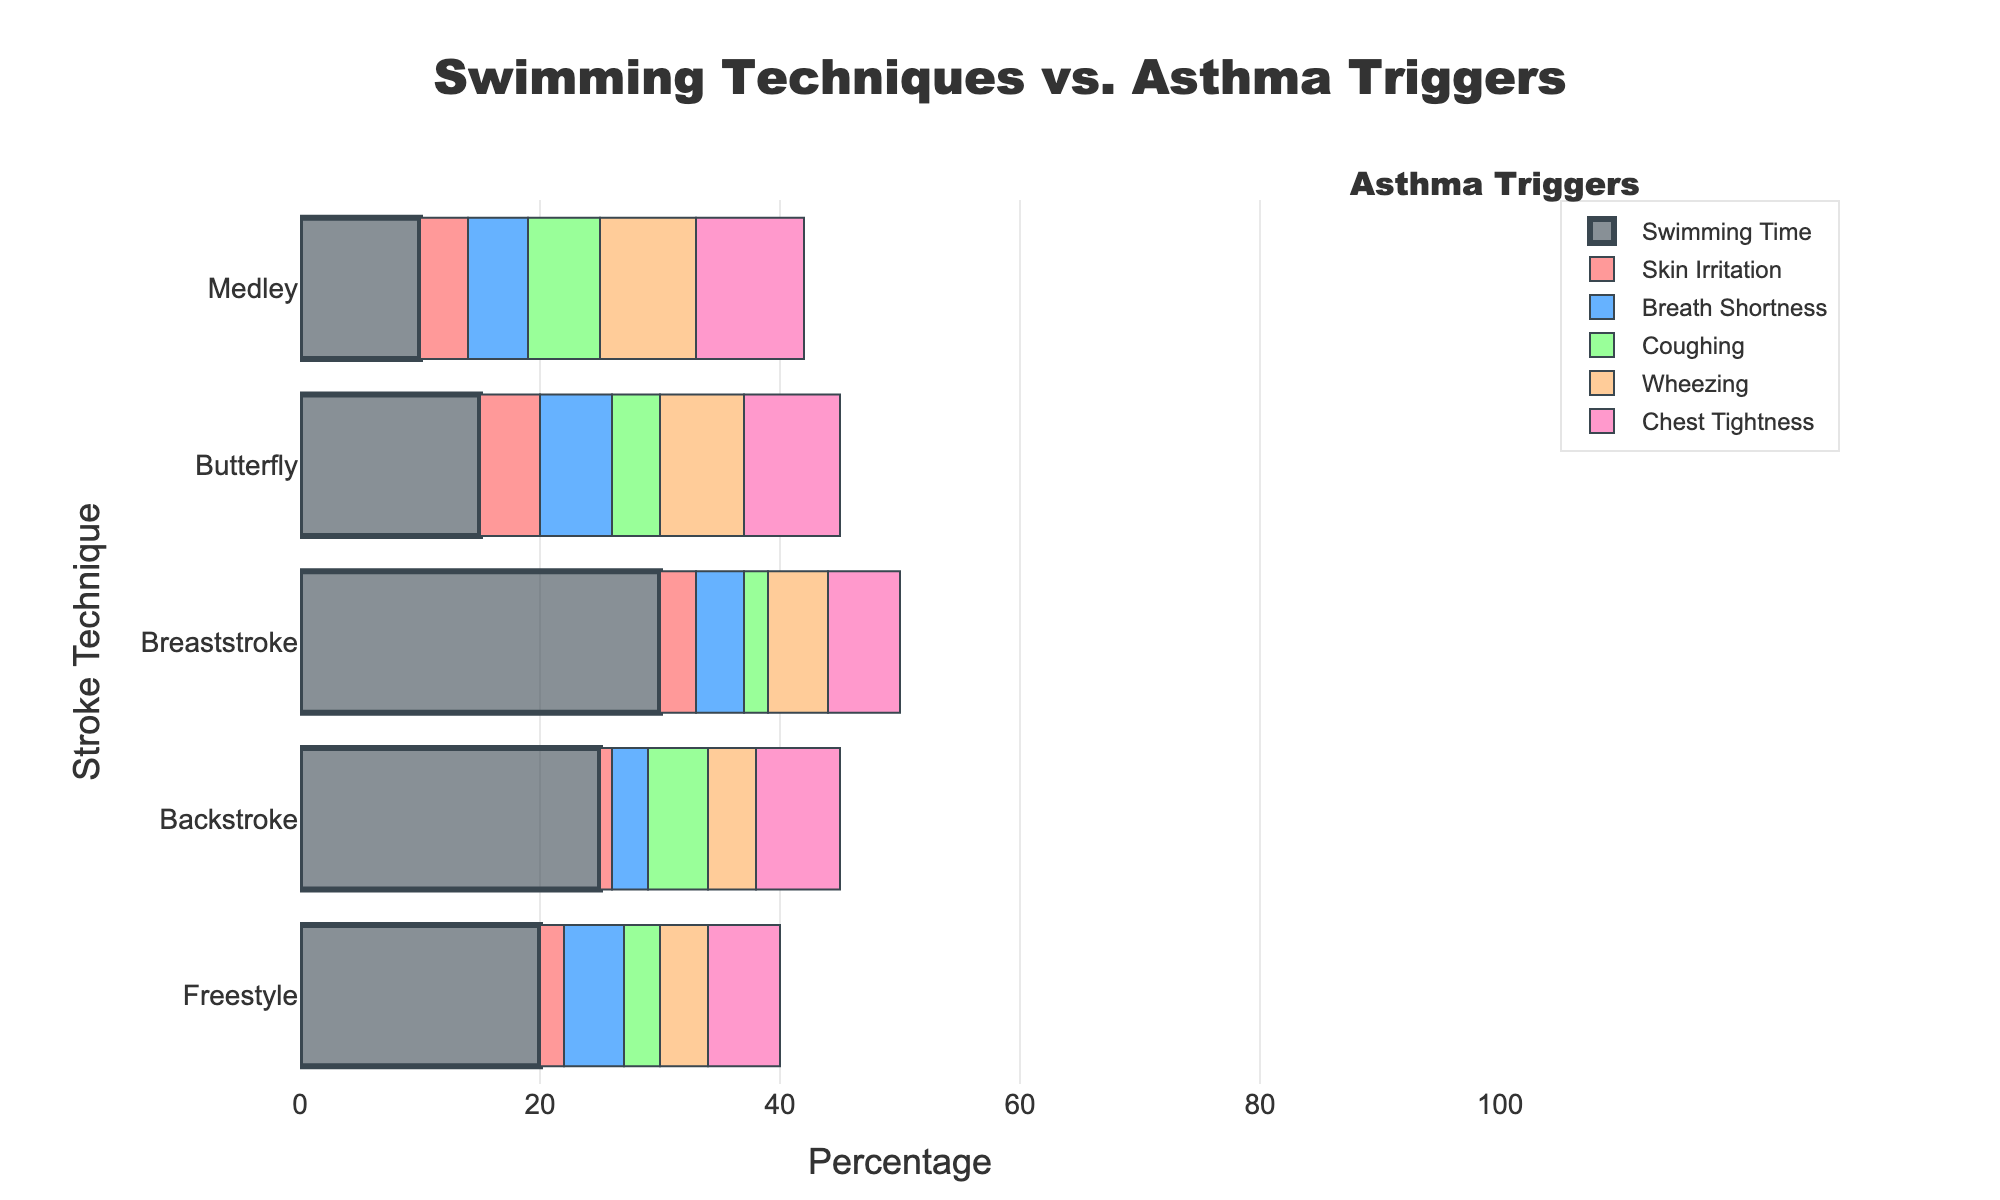Which stroke technique has the highest percentage of swimming time? The chart shows bars for swimming times associated with each stroke technique. The longest bar represents the highest percentage.
Answer: Breaststroke Which asthma trigger has the highest percentage for the Butterfly stroke? For each stroke technique, the chart also breaks down the percentage for different asthma triggers. Look at the segments for Butterfly stroke to find the highest value.
Answer: Chest Tightness Compare the percentages of coughing in Freestyle and Backstroke. Which is higher? Identify the coughing segments for both Freestyle and Backstroke techniques in the chart and compare their lengths to determine which one is higher.
Answer: Backstroke What is the combined percentage for Wheezing in Medley and Butterfly strokes? Locate the segments for Wheezing in both Medley and Butterfly. Sum the percentages given for each technique.
Answer: 15% How much greater is the Chest Tightness percentage in Medley than in Freestyle? Find the segments for Chest Tightness in both Medley and Freestyle. Subtract the Freestyle value from the Medley value.
Answer: 3% Arrange the stroke techniques in decreasing order of Skin Irritation percentage. Examine the chart to observe the segments for Skin Irritation across all techniques, then list them starting from the highest to the lowest.
Answer: Butterfly, Medley, Breaststroke, Freestyle, Backstroke Which stroke technique shows the lowest percentage of Breath Shortness? Look at the Breath Shortness segments for each stroke technique, and identify the smallest one.
Answer: Backstroke What is the total percentage of Wheezing for all stroke techniques combined? Sum the Wheezing percentages for all stroke techniques as observed in the chart.
Answer: 32% Compare the lengths of the swimming time bars for Backstroke and Medley. Which one is longer? Evaluate the bars representing the swimming time for Backstroke and Medley, then assess which bar is visually longer.
Answer: Backstroke 